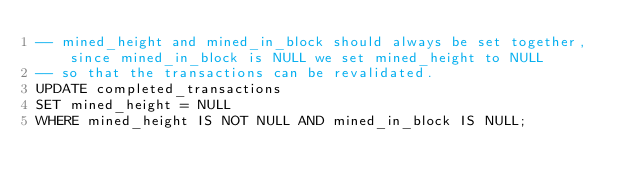<code> <loc_0><loc_0><loc_500><loc_500><_SQL_>-- mined_height and mined_in_block should always be set together, since mined_in_block is NULL we set mined_height to NULL
-- so that the transactions can be revalidated.
UPDATE completed_transactions
SET mined_height = NULL
WHERE mined_height IS NOT NULL AND mined_in_block IS NULL;</code> 